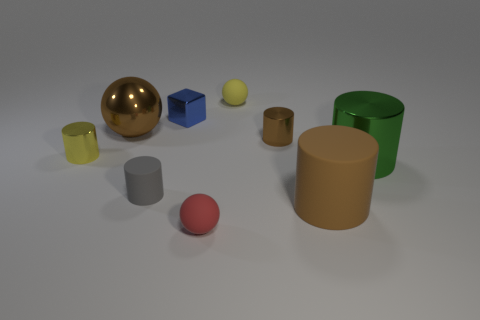Subtract all gray cylinders. How many cylinders are left? 4 Subtract all small matte cylinders. How many cylinders are left? 4 Subtract all blue cylinders. Subtract all brown balls. How many cylinders are left? 5 Subtract all spheres. How many objects are left? 6 Subtract all brown cylinders. Subtract all red objects. How many objects are left? 6 Add 2 yellow metallic cylinders. How many yellow metallic cylinders are left? 3 Add 3 small brown rubber spheres. How many small brown rubber spheres exist? 3 Subtract 0 purple cylinders. How many objects are left? 9 